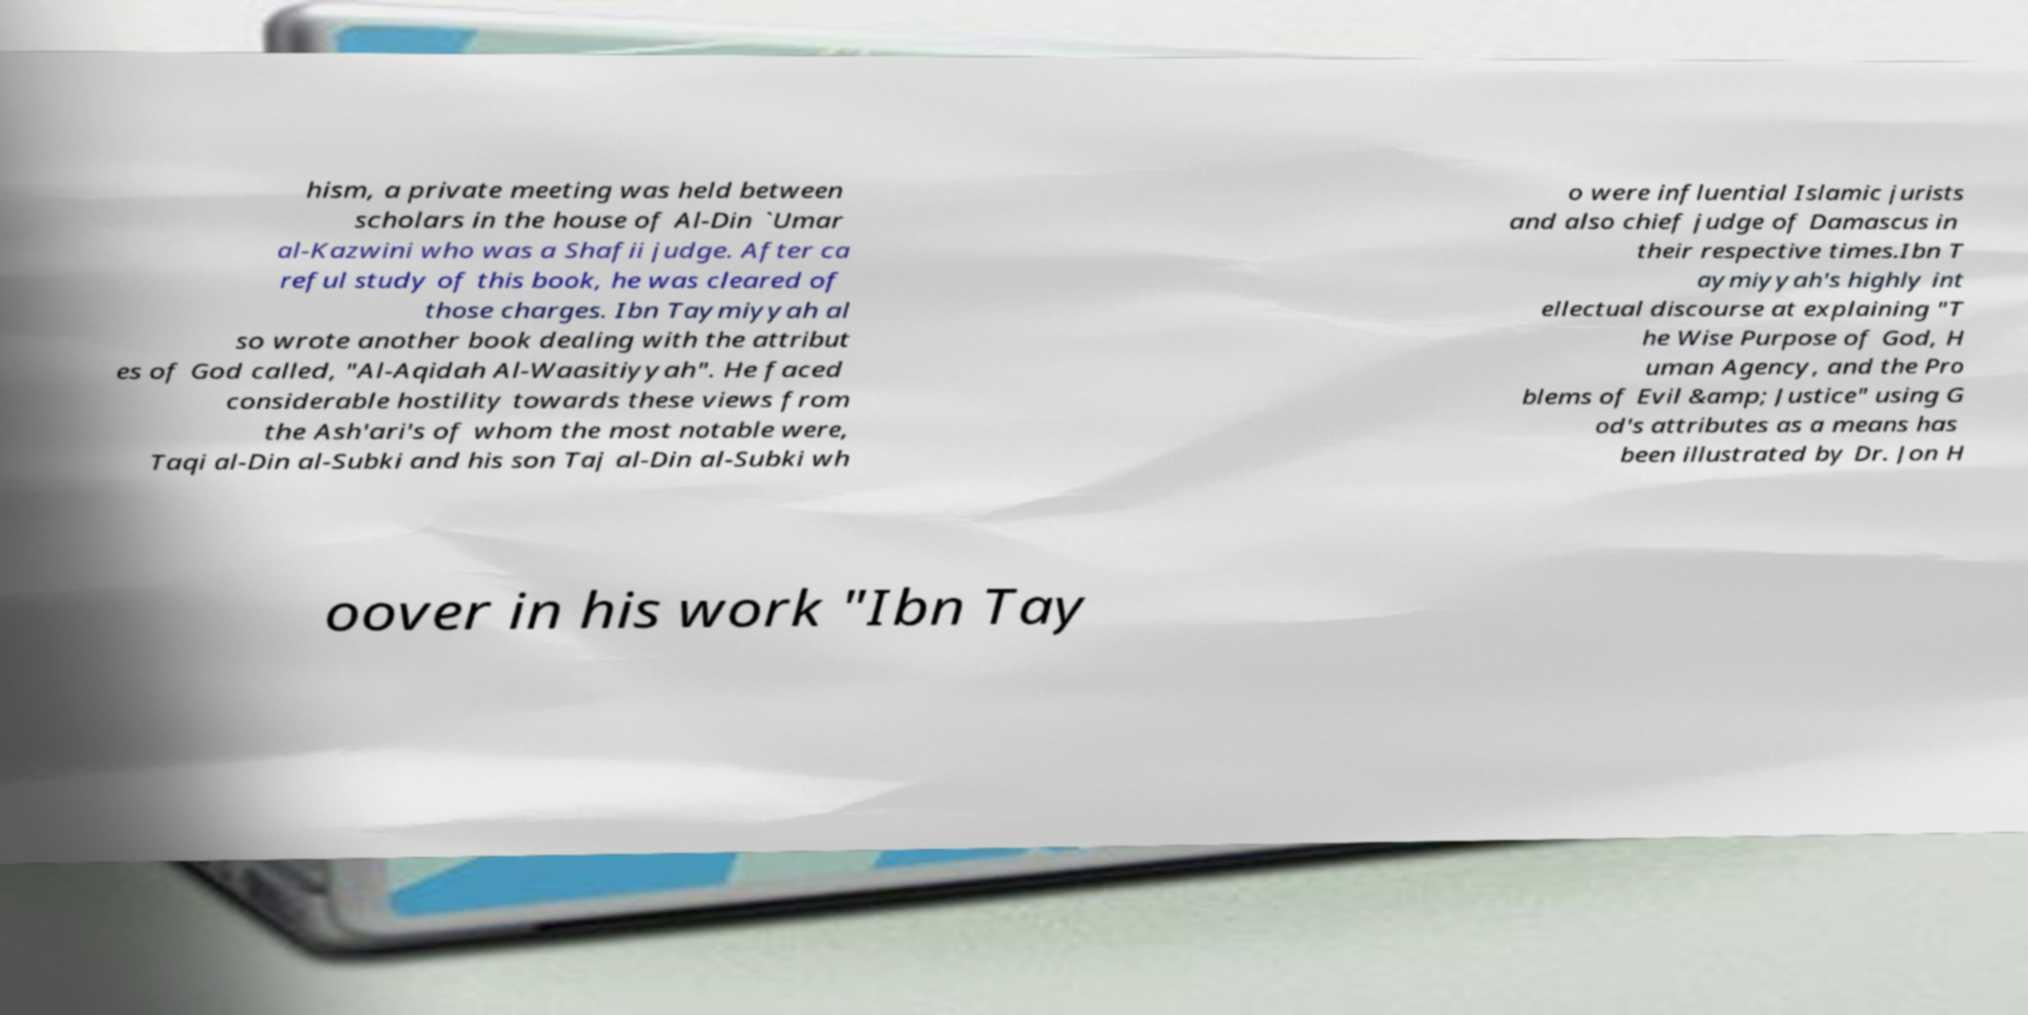Please identify and transcribe the text found in this image. hism, a private meeting was held between scholars in the house of Al-Din `Umar al-Kazwini who was a Shafii judge. After ca reful study of this book, he was cleared of those charges. Ibn Taymiyyah al so wrote another book dealing with the attribut es of God called, "Al-Aqidah Al-Waasitiyyah". He faced considerable hostility towards these views from the Ash'ari's of whom the most notable were, Taqi al-Din al-Subki and his son Taj al-Din al-Subki wh o were influential Islamic jurists and also chief judge of Damascus in their respective times.Ibn T aymiyyah's highly int ellectual discourse at explaining "T he Wise Purpose of God, H uman Agency, and the Pro blems of Evil &amp; Justice" using G od's attributes as a means has been illustrated by Dr. Jon H oover in his work "Ibn Tay 